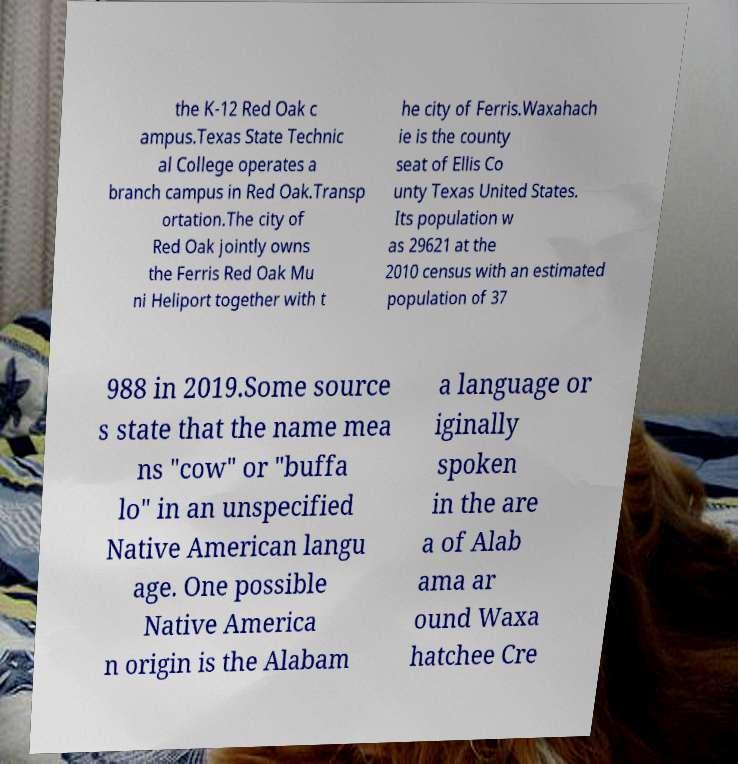Please read and relay the text visible in this image. What does it say? the K-12 Red Oak c ampus.Texas State Technic al College operates a branch campus in Red Oak.Transp ortation.The city of Red Oak jointly owns the Ferris Red Oak Mu ni Heliport together with t he city of Ferris.Waxahach ie is the county seat of Ellis Co unty Texas United States. Its population w as 29621 at the 2010 census with an estimated population of 37 988 in 2019.Some source s state that the name mea ns "cow" or "buffa lo" in an unspecified Native American langu age. One possible Native America n origin is the Alabam a language or iginally spoken in the are a of Alab ama ar ound Waxa hatchee Cre 